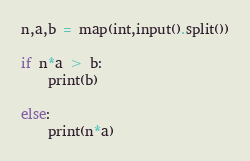Convert code to text. <code><loc_0><loc_0><loc_500><loc_500><_Python_>n,a,b = map(int,input().split())

if n*a > b:
    print(b)
    
else:
    print(n*a)</code> 